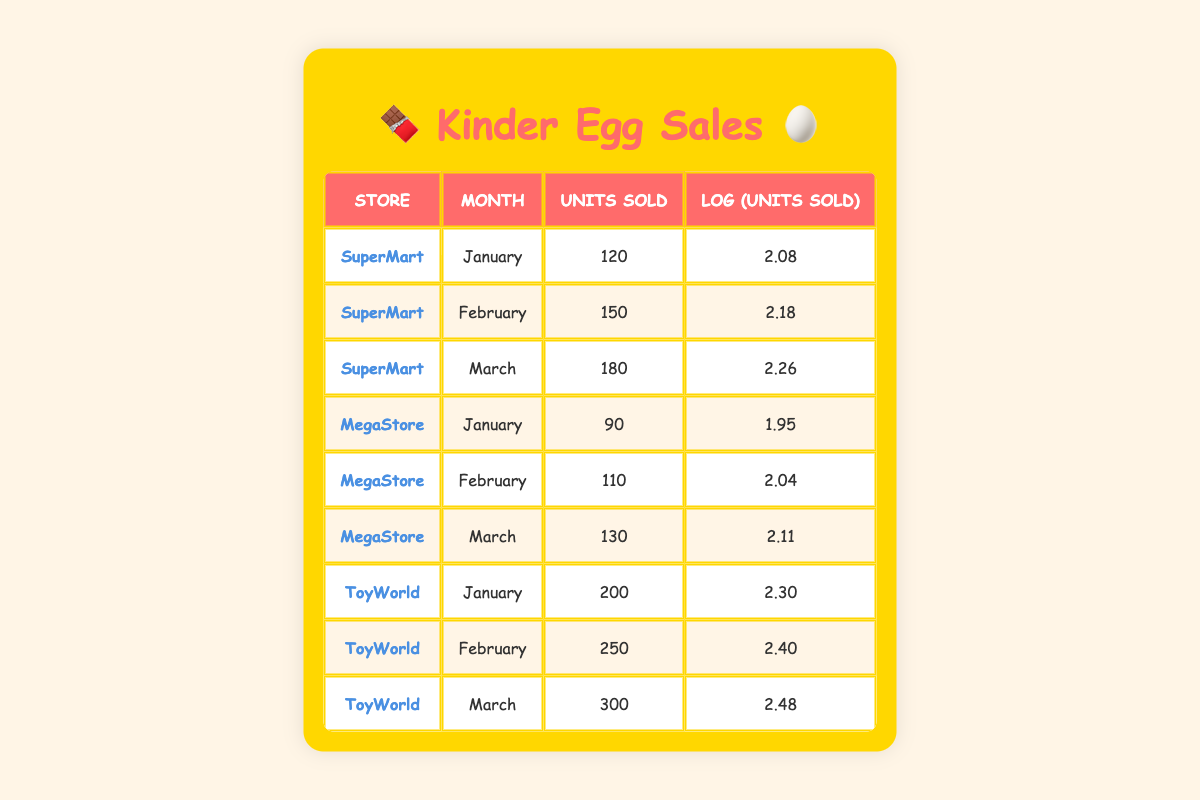What store sold the most Kinder Eggs in March? In March, ToyWorld sold 300 units, SuperMart sold 180 units, and MegaStore sold 130 units. Comparing these, ToyWorld has the highest sales.
Answer: ToyWorld What were the total units sold by SuperMart from January to March? Adding the units sold in January (120), February (150), and March (180) gives a total of 120 + 150 + 180 = 450 units sold.
Answer: 450 Did MegaStore sell more units in February or March? In February, MegaStore sold 110 units, and in March, it sold 130 units. Since 130 is greater than 110, MegaStore sold more units in March.
Answer: Yes What is the average number of units sold by ToyWorld in the first three months? The total units sold by ToyWorld are 200 (January) + 250 (February) + 300 (March) = 750. Dividing this total by 3 (the number of months) gives an average of 750 / 3 = 250 units.
Answer: 250 How many more units did ToyWorld sell in February than MegaStore? ToyWorld sold 250 units in February, while MegaStore sold 110 units. The difference is 250 - 110 = 140 units.
Answer: 140 What is the log value of the units sold by SuperMart in January? The log value of units sold by SuperMart in January is given directly in the table as 2.08.
Answer: 2.08 Did ToyWorld sell less than 250 units in January? In January, ToyWorld sold 200 units. Since 200 is less than 250, the answer is yes.
Answer: Yes Which store had the highest log value of units sold in February? In February, SuperMart had a log value of 2.18, MegaStore had 2.04, and ToyWorld had 2.40. The highest log value is from ToyWorld at 2.40.
Answer: ToyWorld 